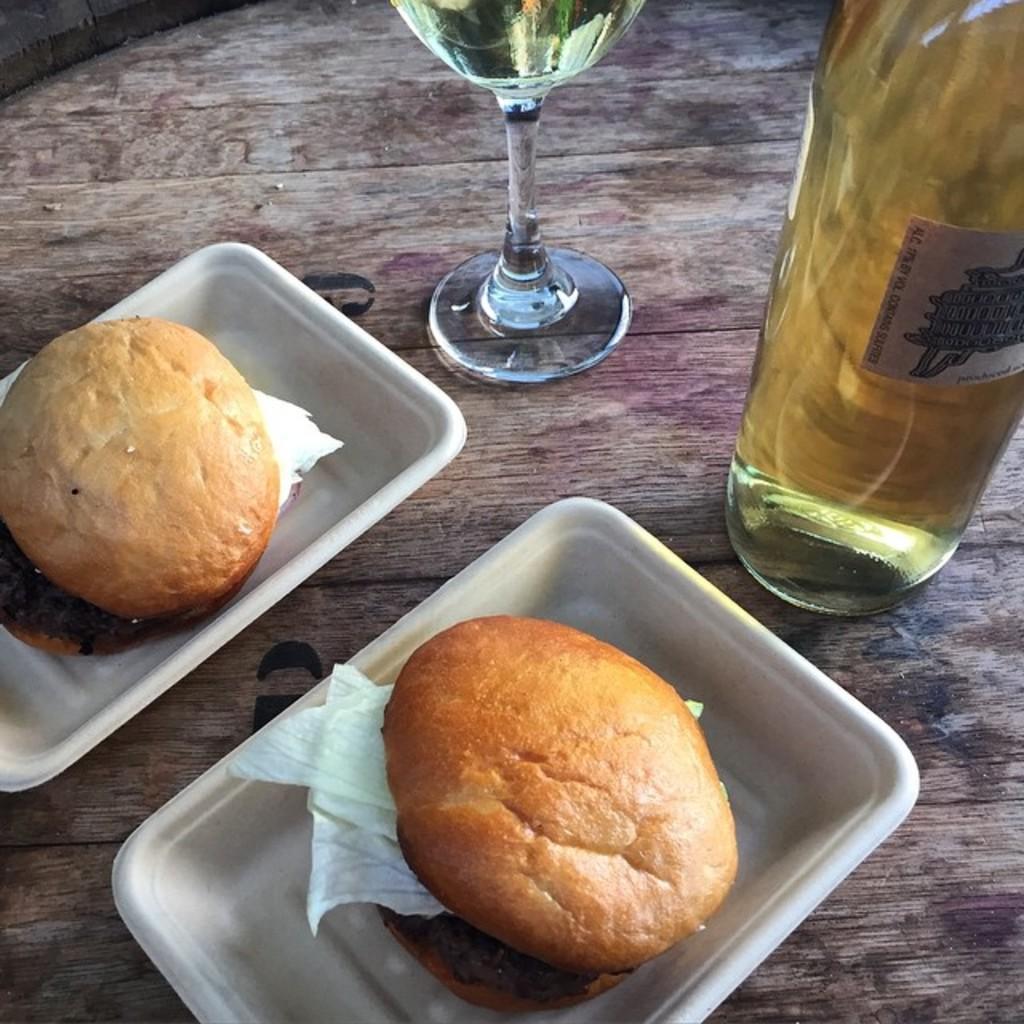Describe this image in one or two sentences. On a wooden table there are 2 bowls which have burgers. There is a glass bottle and a glass of drink. 